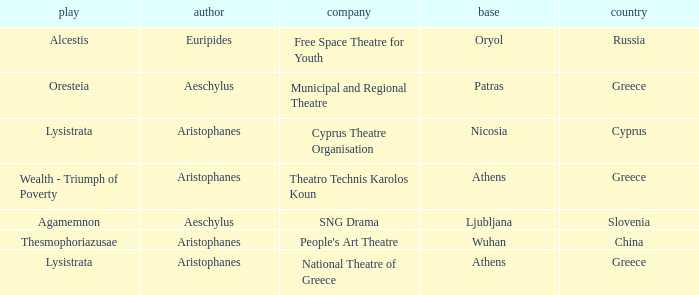What is the company when the base is ljubljana? SNG Drama. 